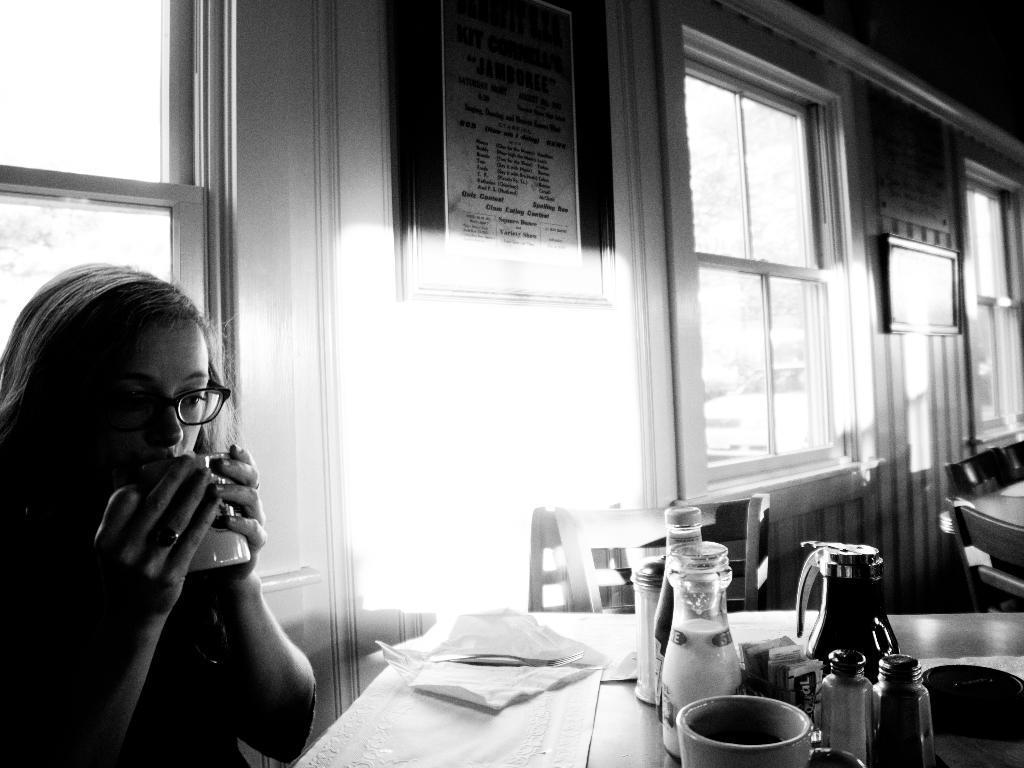Please provide a concise description of this image. The image is inside the room. In the image on left side there is a woman holding a cup and sitting on chair in front of a table. On table we can see a jar,cloth,tissues in background there is a wall,photo frames and a glass window in middle we can also hoardings. 